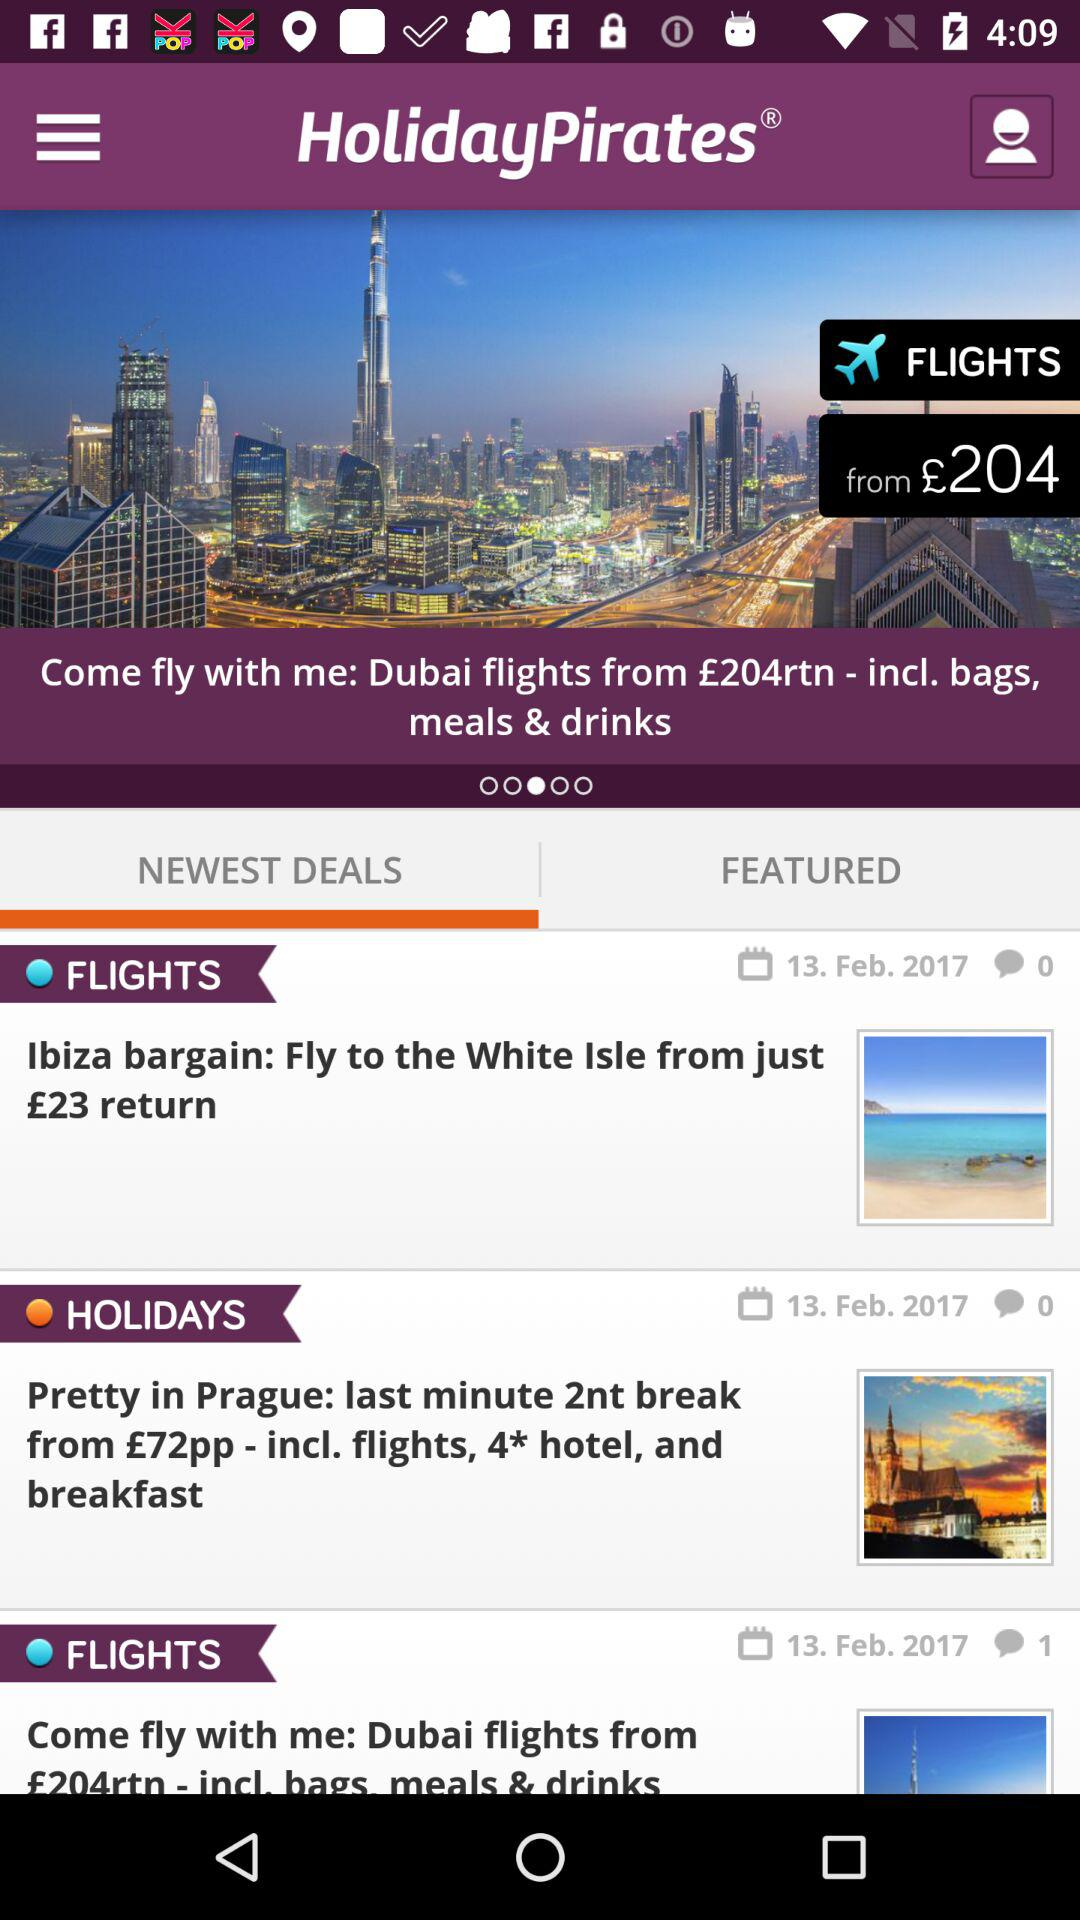What is the starting price of a flight to Dubai? The starting price of a flight to Dubai is £204. 